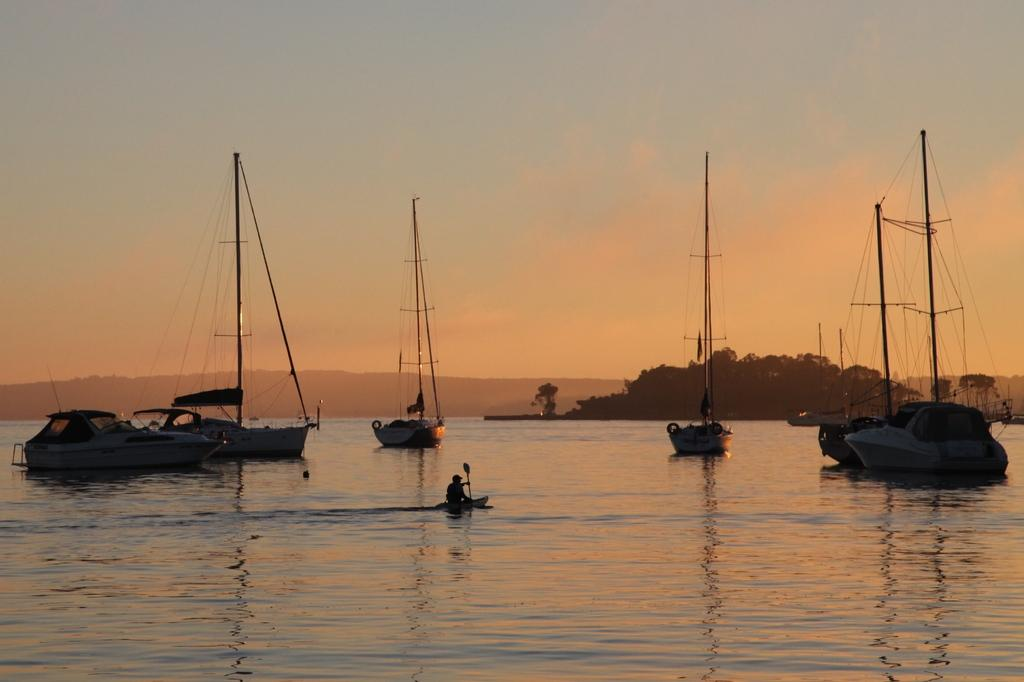What type of vehicles can be seen on the water in the image? There are ships on the water in the image. What is the person in the image doing? There is a person rowing a boat in the image. What type of vegetation is visible in the image? There are trees visible in the image. What is visible at the top of the image? The sky is visible at the top of the image. Where is the railway located in the image? There is no railway present in the image. What type of drawer can be seen in the image? There is no drawer present in the image. 